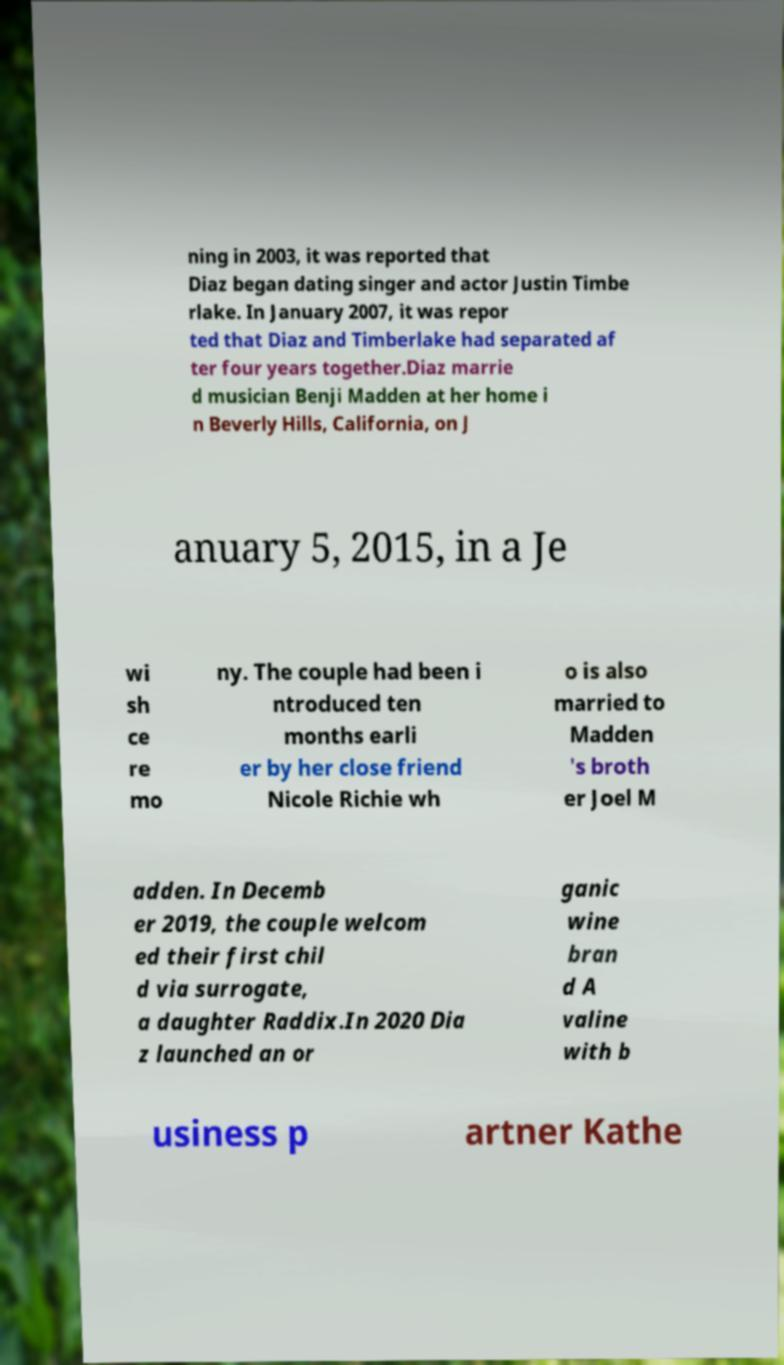What messages or text are displayed in this image? I need them in a readable, typed format. ning in 2003, it was reported that Diaz began dating singer and actor Justin Timbe rlake. In January 2007, it was repor ted that Diaz and Timberlake had separated af ter four years together.Diaz marrie d musician Benji Madden at her home i n Beverly Hills, California, on J anuary 5, 2015, in a Je wi sh ce re mo ny. The couple had been i ntroduced ten months earli er by her close friend Nicole Richie wh o is also married to Madden 's broth er Joel M adden. In Decemb er 2019, the couple welcom ed their first chil d via surrogate, a daughter Raddix.In 2020 Dia z launched an or ganic wine bran d A valine with b usiness p artner Kathe 